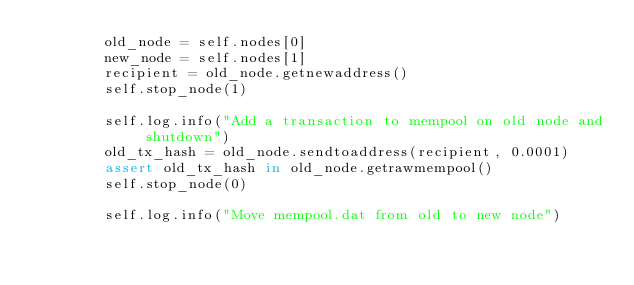Convert code to text. <code><loc_0><loc_0><loc_500><loc_500><_Python_>        old_node = self.nodes[0]
        new_node = self.nodes[1]
        recipient = old_node.getnewaddress()
        self.stop_node(1)

        self.log.info("Add a transaction to mempool on old node and shutdown")
        old_tx_hash = old_node.sendtoaddress(recipient, 0.0001)
        assert old_tx_hash in old_node.getrawmempool()
        self.stop_node(0)

        self.log.info("Move mempool.dat from old to new node")</code> 